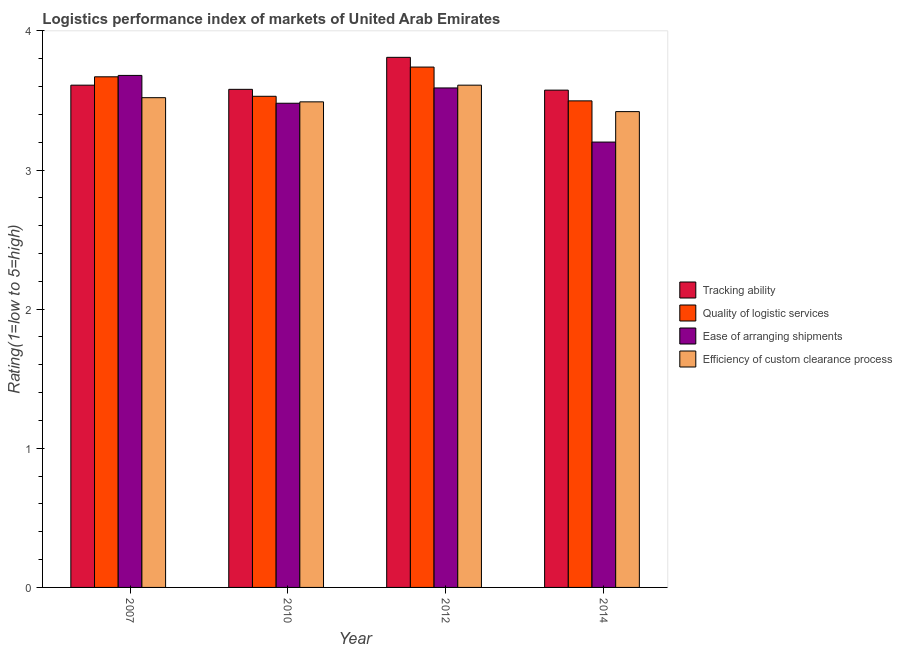How many different coloured bars are there?
Make the answer very short. 4. How many bars are there on the 2nd tick from the left?
Make the answer very short. 4. In how many cases, is the number of bars for a given year not equal to the number of legend labels?
Your response must be concise. 0. What is the lpi rating of ease of arranging shipments in 2010?
Offer a very short reply. 3.48. Across all years, what is the maximum lpi rating of ease of arranging shipments?
Your response must be concise. 3.68. Across all years, what is the minimum lpi rating of quality of logistic services?
Ensure brevity in your answer.  3.5. In which year was the lpi rating of tracking ability maximum?
Make the answer very short. 2012. What is the total lpi rating of tracking ability in the graph?
Your answer should be very brief. 14.57. What is the difference between the lpi rating of tracking ability in 2010 and that in 2014?
Provide a short and direct response. 0.01. What is the difference between the lpi rating of efficiency of custom clearance process in 2012 and the lpi rating of quality of logistic services in 2007?
Make the answer very short. 0.09. What is the average lpi rating of quality of logistic services per year?
Provide a succinct answer. 3.61. In how many years, is the lpi rating of ease of arranging shipments greater than 2.6?
Keep it short and to the point. 4. What is the ratio of the lpi rating of tracking ability in 2010 to that in 2012?
Give a very brief answer. 0.94. Is the lpi rating of ease of arranging shipments in 2007 less than that in 2012?
Ensure brevity in your answer.  No. What is the difference between the highest and the second highest lpi rating of ease of arranging shipments?
Provide a short and direct response. 0.09. What is the difference between the highest and the lowest lpi rating of quality of logistic services?
Offer a terse response. 0.24. In how many years, is the lpi rating of ease of arranging shipments greater than the average lpi rating of ease of arranging shipments taken over all years?
Your answer should be very brief. 2. Is the sum of the lpi rating of quality of logistic services in 2010 and 2014 greater than the maximum lpi rating of efficiency of custom clearance process across all years?
Give a very brief answer. Yes. What does the 3rd bar from the left in 2012 represents?
Keep it short and to the point. Ease of arranging shipments. What does the 1st bar from the right in 2014 represents?
Provide a short and direct response. Efficiency of custom clearance process. Is it the case that in every year, the sum of the lpi rating of tracking ability and lpi rating of quality of logistic services is greater than the lpi rating of ease of arranging shipments?
Offer a very short reply. Yes. How many bars are there?
Your answer should be compact. 16. Are all the bars in the graph horizontal?
Provide a succinct answer. No. How many years are there in the graph?
Keep it short and to the point. 4. Are the values on the major ticks of Y-axis written in scientific E-notation?
Offer a very short reply. No. Does the graph contain any zero values?
Your answer should be very brief. No. Does the graph contain grids?
Your answer should be compact. No. How many legend labels are there?
Your response must be concise. 4. How are the legend labels stacked?
Provide a short and direct response. Vertical. What is the title of the graph?
Your answer should be compact. Logistics performance index of markets of United Arab Emirates. Does "Primary schools" appear as one of the legend labels in the graph?
Keep it short and to the point. No. What is the label or title of the Y-axis?
Give a very brief answer. Rating(1=low to 5=high). What is the Rating(1=low to 5=high) of Tracking ability in 2007?
Offer a very short reply. 3.61. What is the Rating(1=low to 5=high) in Quality of logistic services in 2007?
Offer a very short reply. 3.67. What is the Rating(1=low to 5=high) of Ease of arranging shipments in 2007?
Make the answer very short. 3.68. What is the Rating(1=low to 5=high) of Efficiency of custom clearance process in 2007?
Your response must be concise. 3.52. What is the Rating(1=low to 5=high) in Tracking ability in 2010?
Your response must be concise. 3.58. What is the Rating(1=low to 5=high) of Quality of logistic services in 2010?
Provide a short and direct response. 3.53. What is the Rating(1=low to 5=high) in Ease of arranging shipments in 2010?
Offer a terse response. 3.48. What is the Rating(1=low to 5=high) of Efficiency of custom clearance process in 2010?
Make the answer very short. 3.49. What is the Rating(1=low to 5=high) in Tracking ability in 2012?
Keep it short and to the point. 3.81. What is the Rating(1=low to 5=high) in Quality of logistic services in 2012?
Offer a very short reply. 3.74. What is the Rating(1=low to 5=high) in Ease of arranging shipments in 2012?
Ensure brevity in your answer.  3.59. What is the Rating(1=low to 5=high) in Efficiency of custom clearance process in 2012?
Give a very brief answer. 3.61. What is the Rating(1=low to 5=high) of Tracking ability in 2014?
Ensure brevity in your answer.  3.57. What is the Rating(1=low to 5=high) in Quality of logistic services in 2014?
Provide a short and direct response. 3.5. What is the Rating(1=low to 5=high) in Ease of arranging shipments in 2014?
Your response must be concise. 3.2. What is the Rating(1=low to 5=high) in Efficiency of custom clearance process in 2014?
Provide a succinct answer. 3.42. Across all years, what is the maximum Rating(1=low to 5=high) in Tracking ability?
Ensure brevity in your answer.  3.81. Across all years, what is the maximum Rating(1=low to 5=high) in Quality of logistic services?
Your response must be concise. 3.74. Across all years, what is the maximum Rating(1=low to 5=high) of Ease of arranging shipments?
Your answer should be compact. 3.68. Across all years, what is the maximum Rating(1=low to 5=high) of Efficiency of custom clearance process?
Your answer should be compact. 3.61. Across all years, what is the minimum Rating(1=low to 5=high) of Tracking ability?
Your response must be concise. 3.57. Across all years, what is the minimum Rating(1=low to 5=high) of Quality of logistic services?
Give a very brief answer. 3.5. Across all years, what is the minimum Rating(1=low to 5=high) of Ease of arranging shipments?
Your answer should be very brief. 3.2. Across all years, what is the minimum Rating(1=low to 5=high) of Efficiency of custom clearance process?
Your response must be concise. 3.42. What is the total Rating(1=low to 5=high) of Tracking ability in the graph?
Your answer should be very brief. 14.57. What is the total Rating(1=low to 5=high) of Quality of logistic services in the graph?
Keep it short and to the point. 14.44. What is the total Rating(1=low to 5=high) in Ease of arranging shipments in the graph?
Provide a succinct answer. 13.95. What is the total Rating(1=low to 5=high) in Efficiency of custom clearance process in the graph?
Give a very brief answer. 14.04. What is the difference between the Rating(1=low to 5=high) of Quality of logistic services in 2007 and that in 2010?
Your answer should be very brief. 0.14. What is the difference between the Rating(1=low to 5=high) of Tracking ability in 2007 and that in 2012?
Provide a succinct answer. -0.2. What is the difference between the Rating(1=low to 5=high) in Quality of logistic services in 2007 and that in 2012?
Your answer should be compact. -0.07. What is the difference between the Rating(1=low to 5=high) in Ease of arranging shipments in 2007 and that in 2012?
Your response must be concise. 0.09. What is the difference between the Rating(1=low to 5=high) of Efficiency of custom clearance process in 2007 and that in 2012?
Your answer should be very brief. -0.09. What is the difference between the Rating(1=low to 5=high) of Tracking ability in 2007 and that in 2014?
Make the answer very short. 0.04. What is the difference between the Rating(1=low to 5=high) in Quality of logistic services in 2007 and that in 2014?
Make the answer very short. 0.17. What is the difference between the Rating(1=low to 5=high) in Ease of arranging shipments in 2007 and that in 2014?
Offer a terse response. 0.48. What is the difference between the Rating(1=low to 5=high) of Efficiency of custom clearance process in 2007 and that in 2014?
Your answer should be compact. 0.1. What is the difference between the Rating(1=low to 5=high) of Tracking ability in 2010 and that in 2012?
Offer a very short reply. -0.23. What is the difference between the Rating(1=low to 5=high) in Quality of logistic services in 2010 and that in 2012?
Your response must be concise. -0.21. What is the difference between the Rating(1=low to 5=high) of Ease of arranging shipments in 2010 and that in 2012?
Keep it short and to the point. -0.11. What is the difference between the Rating(1=low to 5=high) in Efficiency of custom clearance process in 2010 and that in 2012?
Offer a terse response. -0.12. What is the difference between the Rating(1=low to 5=high) of Tracking ability in 2010 and that in 2014?
Your answer should be very brief. 0.01. What is the difference between the Rating(1=low to 5=high) of Quality of logistic services in 2010 and that in 2014?
Keep it short and to the point. 0.03. What is the difference between the Rating(1=low to 5=high) in Ease of arranging shipments in 2010 and that in 2014?
Provide a short and direct response. 0.28. What is the difference between the Rating(1=low to 5=high) in Efficiency of custom clearance process in 2010 and that in 2014?
Provide a short and direct response. 0.07. What is the difference between the Rating(1=low to 5=high) in Tracking ability in 2012 and that in 2014?
Provide a short and direct response. 0.24. What is the difference between the Rating(1=low to 5=high) of Quality of logistic services in 2012 and that in 2014?
Your answer should be very brief. 0.24. What is the difference between the Rating(1=low to 5=high) of Ease of arranging shipments in 2012 and that in 2014?
Provide a succinct answer. 0.39. What is the difference between the Rating(1=low to 5=high) in Efficiency of custom clearance process in 2012 and that in 2014?
Your answer should be very brief. 0.19. What is the difference between the Rating(1=low to 5=high) in Tracking ability in 2007 and the Rating(1=low to 5=high) in Quality of logistic services in 2010?
Your answer should be compact. 0.08. What is the difference between the Rating(1=low to 5=high) in Tracking ability in 2007 and the Rating(1=low to 5=high) in Ease of arranging shipments in 2010?
Your answer should be compact. 0.13. What is the difference between the Rating(1=low to 5=high) in Tracking ability in 2007 and the Rating(1=low to 5=high) in Efficiency of custom clearance process in 2010?
Provide a succinct answer. 0.12. What is the difference between the Rating(1=low to 5=high) in Quality of logistic services in 2007 and the Rating(1=low to 5=high) in Ease of arranging shipments in 2010?
Ensure brevity in your answer.  0.19. What is the difference between the Rating(1=low to 5=high) in Quality of logistic services in 2007 and the Rating(1=low to 5=high) in Efficiency of custom clearance process in 2010?
Provide a succinct answer. 0.18. What is the difference between the Rating(1=low to 5=high) in Ease of arranging shipments in 2007 and the Rating(1=low to 5=high) in Efficiency of custom clearance process in 2010?
Provide a succinct answer. 0.19. What is the difference between the Rating(1=low to 5=high) in Tracking ability in 2007 and the Rating(1=low to 5=high) in Quality of logistic services in 2012?
Your answer should be compact. -0.13. What is the difference between the Rating(1=low to 5=high) in Quality of logistic services in 2007 and the Rating(1=low to 5=high) in Ease of arranging shipments in 2012?
Offer a terse response. 0.08. What is the difference between the Rating(1=low to 5=high) of Quality of logistic services in 2007 and the Rating(1=low to 5=high) of Efficiency of custom clearance process in 2012?
Provide a short and direct response. 0.06. What is the difference between the Rating(1=low to 5=high) in Ease of arranging shipments in 2007 and the Rating(1=low to 5=high) in Efficiency of custom clearance process in 2012?
Your answer should be compact. 0.07. What is the difference between the Rating(1=low to 5=high) in Tracking ability in 2007 and the Rating(1=low to 5=high) in Quality of logistic services in 2014?
Your answer should be compact. 0.11. What is the difference between the Rating(1=low to 5=high) of Tracking ability in 2007 and the Rating(1=low to 5=high) of Ease of arranging shipments in 2014?
Provide a short and direct response. 0.41. What is the difference between the Rating(1=low to 5=high) of Tracking ability in 2007 and the Rating(1=low to 5=high) of Efficiency of custom clearance process in 2014?
Your answer should be compact. 0.19. What is the difference between the Rating(1=low to 5=high) in Quality of logistic services in 2007 and the Rating(1=low to 5=high) in Ease of arranging shipments in 2014?
Give a very brief answer. 0.47. What is the difference between the Rating(1=low to 5=high) of Quality of logistic services in 2007 and the Rating(1=low to 5=high) of Efficiency of custom clearance process in 2014?
Keep it short and to the point. 0.25. What is the difference between the Rating(1=low to 5=high) in Ease of arranging shipments in 2007 and the Rating(1=low to 5=high) in Efficiency of custom clearance process in 2014?
Your answer should be very brief. 0.26. What is the difference between the Rating(1=low to 5=high) of Tracking ability in 2010 and the Rating(1=low to 5=high) of Quality of logistic services in 2012?
Ensure brevity in your answer.  -0.16. What is the difference between the Rating(1=low to 5=high) of Tracking ability in 2010 and the Rating(1=low to 5=high) of Ease of arranging shipments in 2012?
Ensure brevity in your answer.  -0.01. What is the difference between the Rating(1=low to 5=high) in Tracking ability in 2010 and the Rating(1=low to 5=high) in Efficiency of custom clearance process in 2012?
Ensure brevity in your answer.  -0.03. What is the difference between the Rating(1=low to 5=high) of Quality of logistic services in 2010 and the Rating(1=low to 5=high) of Ease of arranging shipments in 2012?
Give a very brief answer. -0.06. What is the difference between the Rating(1=low to 5=high) in Quality of logistic services in 2010 and the Rating(1=low to 5=high) in Efficiency of custom clearance process in 2012?
Your answer should be very brief. -0.08. What is the difference between the Rating(1=low to 5=high) of Ease of arranging shipments in 2010 and the Rating(1=low to 5=high) of Efficiency of custom clearance process in 2012?
Keep it short and to the point. -0.13. What is the difference between the Rating(1=low to 5=high) in Tracking ability in 2010 and the Rating(1=low to 5=high) in Quality of logistic services in 2014?
Provide a short and direct response. 0.08. What is the difference between the Rating(1=low to 5=high) of Tracking ability in 2010 and the Rating(1=low to 5=high) of Ease of arranging shipments in 2014?
Provide a succinct answer. 0.38. What is the difference between the Rating(1=low to 5=high) in Tracking ability in 2010 and the Rating(1=low to 5=high) in Efficiency of custom clearance process in 2014?
Your answer should be very brief. 0.16. What is the difference between the Rating(1=low to 5=high) in Quality of logistic services in 2010 and the Rating(1=low to 5=high) in Ease of arranging shipments in 2014?
Offer a very short reply. 0.33. What is the difference between the Rating(1=low to 5=high) in Quality of logistic services in 2010 and the Rating(1=low to 5=high) in Efficiency of custom clearance process in 2014?
Your answer should be compact. 0.11. What is the difference between the Rating(1=low to 5=high) of Ease of arranging shipments in 2010 and the Rating(1=low to 5=high) of Efficiency of custom clearance process in 2014?
Provide a succinct answer. 0.06. What is the difference between the Rating(1=low to 5=high) in Tracking ability in 2012 and the Rating(1=low to 5=high) in Quality of logistic services in 2014?
Provide a short and direct response. 0.31. What is the difference between the Rating(1=low to 5=high) in Tracking ability in 2012 and the Rating(1=low to 5=high) in Ease of arranging shipments in 2014?
Give a very brief answer. 0.61. What is the difference between the Rating(1=low to 5=high) in Tracking ability in 2012 and the Rating(1=low to 5=high) in Efficiency of custom clearance process in 2014?
Your answer should be compact. 0.39. What is the difference between the Rating(1=low to 5=high) of Quality of logistic services in 2012 and the Rating(1=low to 5=high) of Ease of arranging shipments in 2014?
Provide a short and direct response. 0.54. What is the difference between the Rating(1=low to 5=high) in Quality of logistic services in 2012 and the Rating(1=low to 5=high) in Efficiency of custom clearance process in 2014?
Make the answer very short. 0.32. What is the difference between the Rating(1=low to 5=high) of Ease of arranging shipments in 2012 and the Rating(1=low to 5=high) of Efficiency of custom clearance process in 2014?
Offer a terse response. 0.17. What is the average Rating(1=low to 5=high) of Tracking ability per year?
Give a very brief answer. 3.64. What is the average Rating(1=low to 5=high) of Quality of logistic services per year?
Make the answer very short. 3.61. What is the average Rating(1=low to 5=high) in Ease of arranging shipments per year?
Offer a terse response. 3.49. What is the average Rating(1=low to 5=high) of Efficiency of custom clearance process per year?
Offer a terse response. 3.51. In the year 2007, what is the difference between the Rating(1=low to 5=high) of Tracking ability and Rating(1=low to 5=high) of Quality of logistic services?
Make the answer very short. -0.06. In the year 2007, what is the difference between the Rating(1=low to 5=high) in Tracking ability and Rating(1=low to 5=high) in Ease of arranging shipments?
Keep it short and to the point. -0.07. In the year 2007, what is the difference between the Rating(1=low to 5=high) in Tracking ability and Rating(1=low to 5=high) in Efficiency of custom clearance process?
Provide a short and direct response. 0.09. In the year 2007, what is the difference between the Rating(1=low to 5=high) in Quality of logistic services and Rating(1=low to 5=high) in Ease of arranging shipments?
Offer a very short reply. -0.01. In the year 2007, what is the difference between the Rating(1=low to 5=high) of Quality of logistic services and Rating(1=low to 5=high) of Efficiency of custom clearance process?
Your answer should be very brief. 0.15. In the year 2007, what is the difference between the Rating(1=low to 5=high) of Ease of arranging shipments and Rating(1=low to 5=high) of Efficiency of custom clearance process?
Offer a terse response. 0.16. In the year 2010, what is the difference between the Rating(1=low to 5=high) in Tracking ability and Rating(1=low to 5=high) in Ease of arranging shipments?
Make the answer very short. 0.1. In the year 2010, what is the difference between the Rating(1=low to 5=high) of Tracking ability and Rating(1=low to 5=high) of Efficiency of custom clearance process?
Your answer should be very brief. 0.09. In the year 2010, what is the difference between the Rating(1=low to 5=high) in Quality of logistic services and Rating(1=low to 5=high) in Efficiency of custom clearance process?
Offer a very short reply. 0.04. In the year 2010, what is the difference between the Rating(1=low to 5=high) in Ease of arranging shipments and Rating(1=low to 5=high) in Efficiency of custom clearance process?
Your response must be concise. -0.01. In the year 2012, what is the difference between the Rating(1=low to 5=high) in Tracking ability and Rating(1=low to 5=high) in Quality of logistic services?
Ensure brevity in your answer.  0.07. In the year 2012, what is the difference between the Rating(1=low to 5=high) in Tracking ability and Rating(1=low to 5=high) in Ease of arranging shipments?
Provide a succinct answer. 0.22. In the year 2012, what is the difference between the Rating(1=low to 5=high) in Quality of logistic services and Rating(1=low to 5=high) in Efficiency of custom clearance process?
Keep it short and to the point. 0.13. In the year 2012, what is the difference between the Rating(1=low to 5=high) in Ease of arranging shipments and Rating(1=low to 5=high) in Efficiency of custom clearance process?
Give a very brief answer. -0.02. In the year 2014, what is the difference between the Rating(1=low to 5=high) in Tracking ability and Rating(1=low to 5=high) in Quality of logistic services?
Your response must be concise. 0.08. In the year 2014, what is the difference between the Rating(1=low to 5=high) of Tracking ability and Rating(1=low to 5=high) of Ease of arranging shipments?
Offer a very short reply. 0.37. In the year 2014, what is the difference between the Rating(1=low to 5=high) in Tracking ability and Rating(1=low to 5=high) in Efficiency of custom clearance process?
Provide a short and direct response. 0.15. In the year 2014, what is the difference between the Rating(1=low to 5=high) of Quality of logistic services and Rating(1=low to 5=high) of Ease of arranging shipments?
Provide a short and direct response. 0.3. In the year 2014, what is the difference between the Rating(1=low to 5=high) in Quality of logistic services and Rating(1=low to 5=high) in Efficiency of custom clearance process?
Provide a succinct answer. 0.08. In the year 2014, what is the difference between the Rating(1=low to 5=high) in Ease of arranging shipments and Rating(1=low to 5=high) in Efficiency of custom clearance process?
Offer a terse response. -0.22. What is the ratio of the Rating(1=low to 5=high) in Tracking ability in 2007 to that in 2010?
Your response must be concise. 1.01. What is the ratio of the Rating(1=low to 5=high) of Quality of logistic services in 2007 to that in 2010?
Your response must be concise. 1.04. What is the ratio of the Rating(1=low to 5=high) of Ease of arranging shipments in 2007 to that in 2010?
Your response must be concise. 1.06. What is the ratio of the Rating(1=low to 5=high) in Efficiency of custom clearance process in 2007 to that in 2010?
Provide a succinct answer. 1.01. What is the ratio of the Rating(1=low to 5=high) of Tracking ability in 2007 to that in 2012?
Offer a terse response. 0.95. What is the ratio of the Rating(1=low to 5=high) of Quality of logistic services in 2007 to that in 2012?
Provide a succinct answer. 0.98. What is the ratio of the Rating(1=low to 5=high) of Ease of arranging shipments in 2007 to that in 2012?
Offer a terse response. 1.03. What is the ratio of the Rating(1=low to 5=high) in Efficiency of custom clearance process in 2007 to that in 2012?
Provide a short and direct response. 0.98. What is the ratio of the Rating(1=low to 5=high) of Quality of logistic services in 2007 to that in 2014?
Provide a short and direct response. 1.05. What is the ratio of the Rating(1=low to 5=high) of Ease of arranging shipments in 2007 to that in 2014?
Make the answer very short. 1.15. What is the ratio of the Rating(1=low to 5=high) in Efficiency of custom clearance process in 2007 to that in 2014?
Offer a very short reply. 1.03. What is the ratio of the Rating(1=low to 5=high) in Tracking ability in 2010 to that in 2012?
Your answer should be compact. 0.94. What is the ratio of the Rating(1=low to 5=high) in Quality of logistic services in 2010 to that in 2012?
Give a very brief answer. 0.94. What is the ratio of the Rating(1=low to 5=high) of Ease of arranging shipments in 2010 to that in 2012?
Offer a terse response. 0.97. What is the ratio of the Rating(1=low to 5=high) of Efficiency of custom clearance process in 2010 to that in 2012?
Provide a succinct answer. 0.97. What is the ratio of the Rating(1=low to 5=high) in Quality of logistic services in 2010 to that in 2014?
Offer a terse response. 1.01. What is the ratio of the Rating(1=low to 5=high) in Ease of arranging shipments in 2010 to that in 2014?
Make the answer very short. 1.09. What is the ratio of the Rating(1=low to 5=high) of Efficiency of custom clearance process in 2010 to that in 2014?
Your response must be concise. 1.02. What is the ratio of the Rating(1=low to 5=high) of Tracking ability in 2012 to that in 2014?
Your answer should be very brief. 1.07. What is the ratio of the Rating(1=low to 5=high) in Quality of logistic services in 2012 to that in 2014?
Your answer should be compact. 1.07. What is the ratio of the Rating(1=low to 5=high) in Ease of arranging shipments in 2012 to that in 2014?
Ensure brevity in your answer.  1.12. What is the ratio of the Rating(1=low to 5=high) in Efficiency of custom clearance process in 2012 to that in 2014?
Offer a terse response. 1.06. What is the difference between the highest and the second highest Rating(1=low to 5=high) of Quality of logistic services?
Keep it short and to the point. 0.07. What is the difference between the highest and the second highest Rating(1=low to 5=high) of Ease of arranging shipments?
Your answer should be compact. 0.09. What is the difference between the highest and the second highest Rating(1=low to 5=high) in Efficiency of custom clearance process?
Provide a succinct answer. 0.09. What is the difference between the highest and the lowest Rating(1=low to 5=high) of Tracking ability?
Give a very brief answer. 0.24. What is the difference between the highest and the lowest Rating(1=low to 5=high) of Quality of logistic services?
Offer a terse response. 0.24. What is the difference between the highest and the lowest Rating(1=low to 5=high) of Ease of arranging shipments?
Ensure brevity in your answer.  0.48. What is the difference between the highest and the lowest Rating(1=low to 5=high) in Efficiency of custom clearance process?
Give a very brief answer. 0.19. 